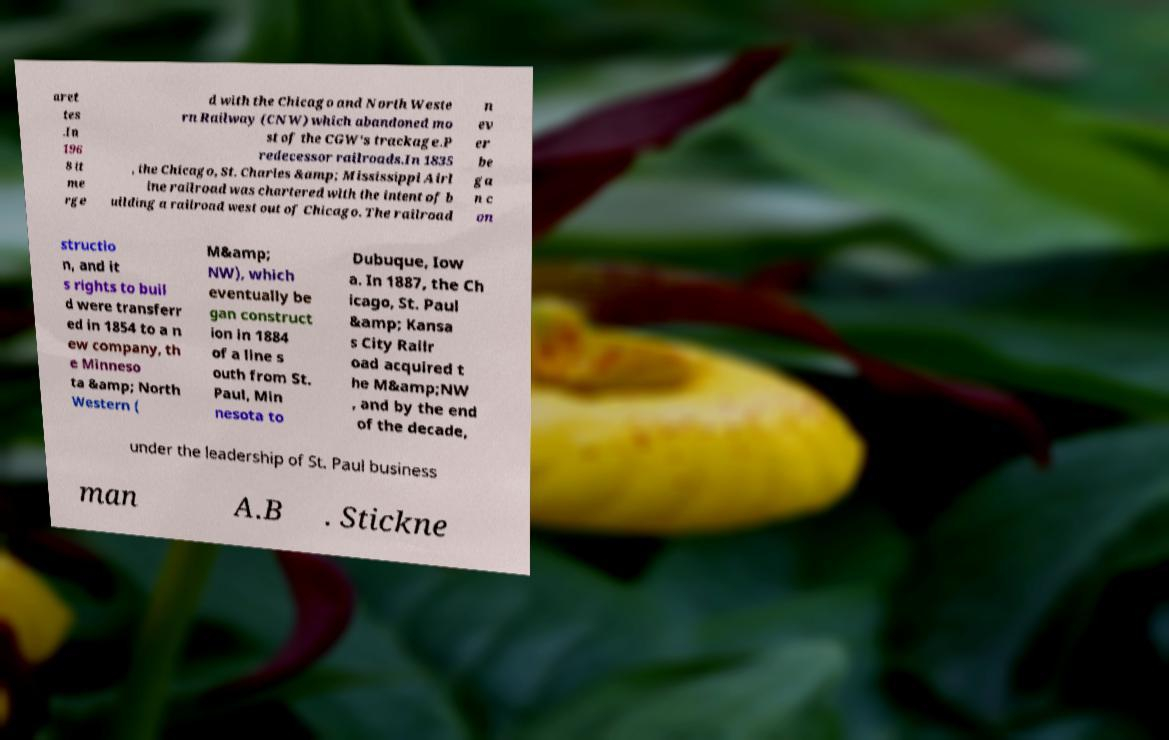Could you extract and type out the text from this image? aret tes .In 196 8 it me rge d with the Chicago and North Weste rn Railway (CNW) which abandoned mo st of the CGW's trackage.P redecessor railroads.In 1835 , the Chicago, St. Charles &amp; Mississippi Airl ine railroad was chartered with the intent of b uilding a railroad west out of Chicago. The railroad n ev er be ga n c on structio n, and it s rights to buil d were transferr ed in 1854 to a n ew company, th e Minneso ta &amp; North Western ( M&amp; NW), which eventually be gan construct ion in 1884 of a line s outh from St. Paul, Min nesota to Dubuque, Iow a. In 1887, the Ch icago, St. Paul &amp; Kansa s City Railr oad acquired t he M&amp;NW , and by the end of the decade, under the leadership of St. Paul business man A.B . Stickne 